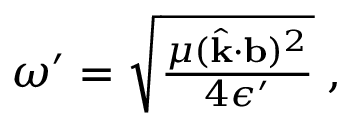<formula> <loc_0><loc_0><loc_500><loc_500>\begin{array} { r } { \omega ^ { \prime } = \sqrt { \frac { \mu ( \hat { k } \cdot { b } ) ^ { 2 } } { 4 \epsilon ^ { \prime } } } \, , } \end{array}</formula> 